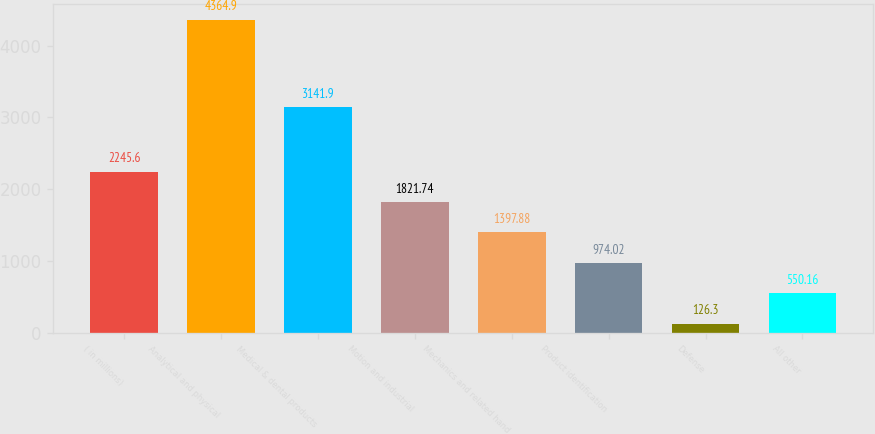Convert chart. <chart><loc_0><loc_0><loc_500><loc_500><bar_chart><fcel>( in millions)<fcel>Analytical and physical<fcel>Medical & dental products<fcel>Motion and industrial<fcel>Mechanics and related hand<fcel>Product identification<fcel>Defense<fcel>All other<nl><fcel>2245.6<fcel>4364.9<fcel>3141.9<fcel>1821.74<fcel>1397.88<fcel>974.02<fcel>126.3<fcel>550.16<nl></chart> 